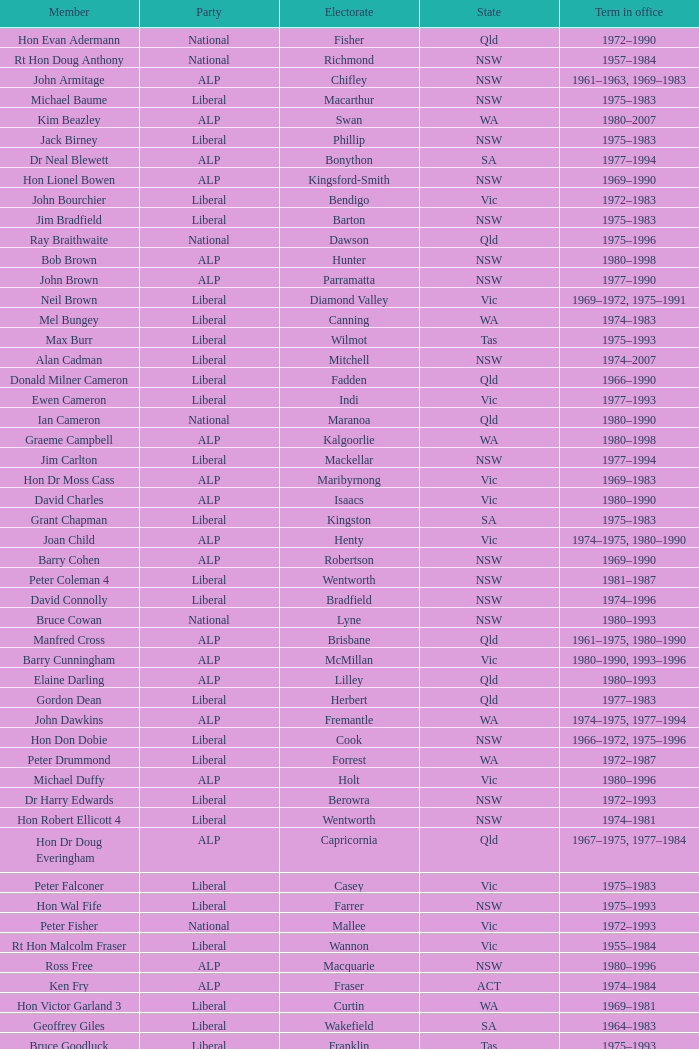To what party does Ralph Jacobi belong? ALP. 